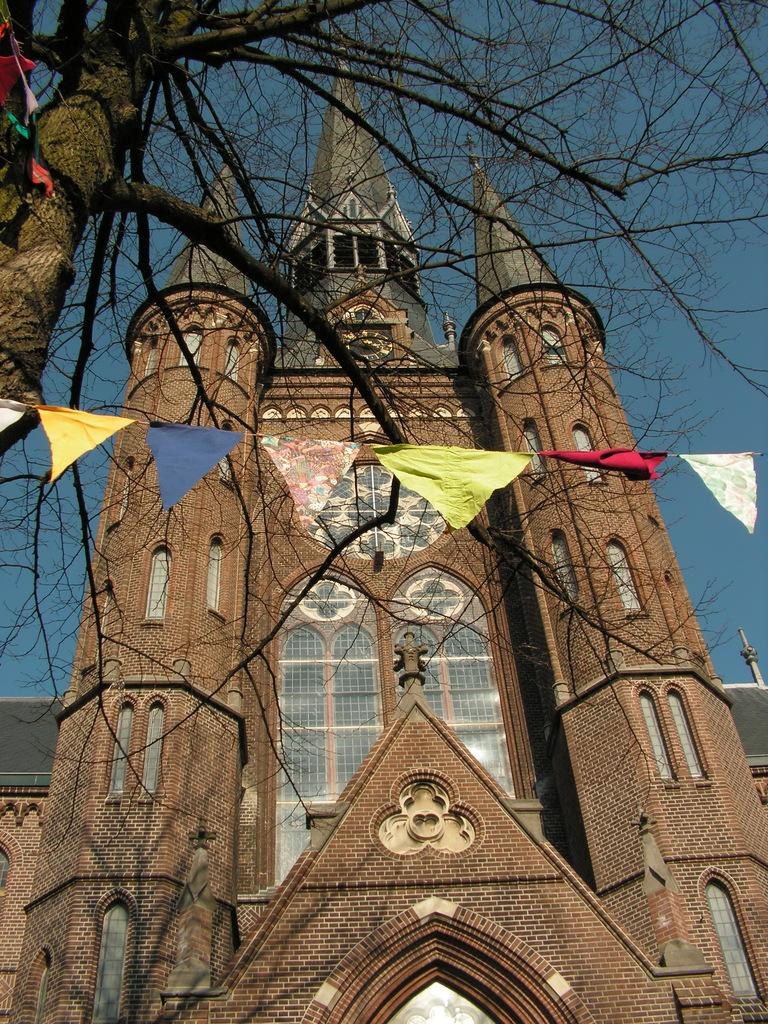What is the main structure in the middle of the image? There is a building in the middle of the image. What type of vegetation is on the left side of the image? There is a tree on the left side of the image. What object made of paper can be seen in the image? There is a paper in the image. What is visible at the top of the image? The sky is visible at the top of the image. What type of card can be seen providing pleasure to the tree in the image? There is no card present in the image, and trees do not experience pleasure. 